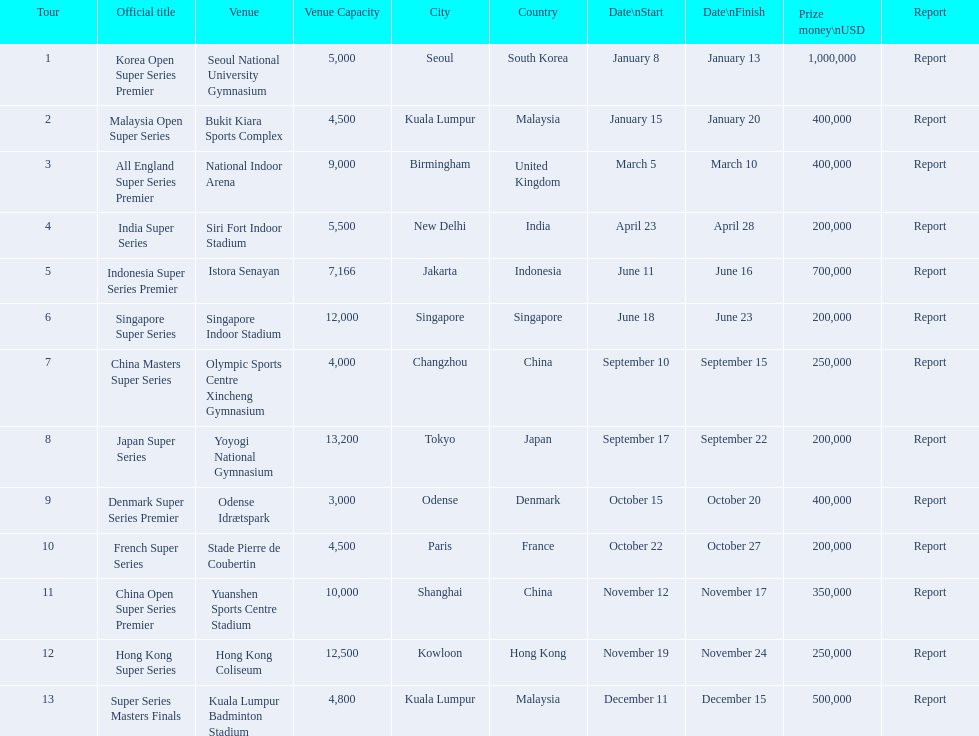What are all the titles? Korea Open Super Series Premier, Malaysia Open Super Series, All England Super Series Premier, India Super Series, Indonesia Super Series Premier, Singapore Super Series, China Masters Super Series, Japan Super Series, Denmark Super Series Premier, French Super Series, China Open Super Series Premier, Hong Kong Super Series, Super Series Masters Finals. When did they take place? January 8, January 15, March 5, April 23, June 11, June 18, September 10, September 17, October 15, October 22, November 12, November 19, December 11. Which title took place in december? Super Series Masters Finals. Could you parse the entire table? {'header': ['Tour', 'Official title', 'Venue', 'Venue Capacity', 'City', 'Country', 'Date\\nStart', 'Date\\nFinish', 'Prize money\\nUSD', 'Report'], 'rows': [['1', 'Korea Open Super Series Premier', 'Seoul National University Gymnasium', '5,000', 'Seoul', 'South Korea', 'January 8', 'January 13', '1,000,000', 'Report'], ['2', 'Malaysia Open Super Series', 'Bukit Kiara Sports Complex', '4,500', 'Kuala Lumpur', 'Malaysia', 'January 15', 'January 20', '400,000', 'Report'], ['3', 'All England Super Series Premier', 'National Indoor Arena', '9,000', 'Birmingham', 'United Kingdom', 'March 5', 'March 10', '400,000', 'Report'], ['4', 'India Super Series', 'Siri Fort Indoor Stadium', '5,500', 'New Delhi', 'India', 'April 23', 'April 28', '200,000', 'Report'], ['5', 'Indonesia Super Series Premier', 'Istora Senayan', '7,166', 'Jakarta', 'Indonesia', 'June 11', 'June 16', '700,000', 'Report'], ['6', 'Singapore Super Series', 'Singapore Indoor Stadium', '12,000', 'Singapore', 'Singapore', 'June 18', 'June 23', '200,000', 'Report'], ['7', 'China Masters Super Series', 'Olympic Sports Centre Xincheng Gymnasium', '4,000', 'Changzhou', 'China', 'September 10', 'September 15', '250,000', 'Report'], ['8', 'Japan Super Series', 'Yoyogi National Gymnasium', '13,200', 'Tokyo', 'Japan', 'September 17', 'September 22', '200,000', 'Report'], ['9', 'Denmark Super Series Premier', 'Odense Idrætspark', '3,000', 'Odense', 'Denmark', 'October 15', 'October 20', '400,000', 'Report'], ['10', 'French Super Series', 'Stade Pierre de Coubertin', '4,500', 'Paris', 'France', 'October 22', 'October 27', '200,000', 'Report'], ['11', 'China Open Super Series Premier', 'Yuanshen Sports Centre Stadium', '10,000', 'Shanghai', 'China', 'November 12', 'November 17', '350,000', 'Report'], ['12', 'Hong Kong Super Series', 'Hong Kong Coliseum', '12,500', 'Kowloon', 'Hong Kong', 'November 19', 'November 24', '250,000', 'Report'], ['13', 'Super Series Masters Finals', 'Kuala Lumpur Badminton Stadium', '4,800', 'Kuala Lumpur', 'Malaysia', 'December 11', 'December 15', '500,000', 'Report']]} 